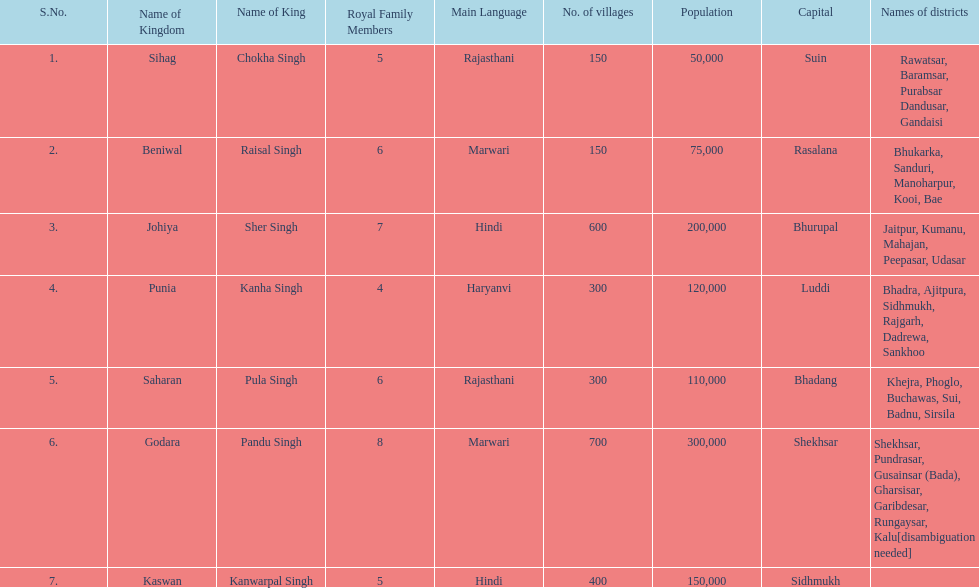After sihag, what kingdom is listed next? Beniwal. 